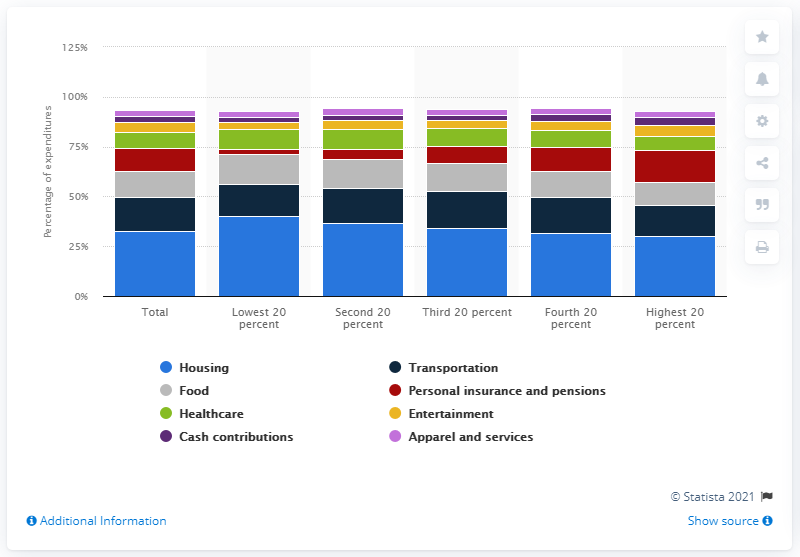Highlight a few significant elements in this photo. In 2019, the highest 20% of consumer units spent 29.9% of their total expenditure on housing, which is a significant portion of their overall expenditure on housing. In 2019, the lowest 20 percent of income consumer units spent approximately 40.2 percent of their total expenditure on housing. 